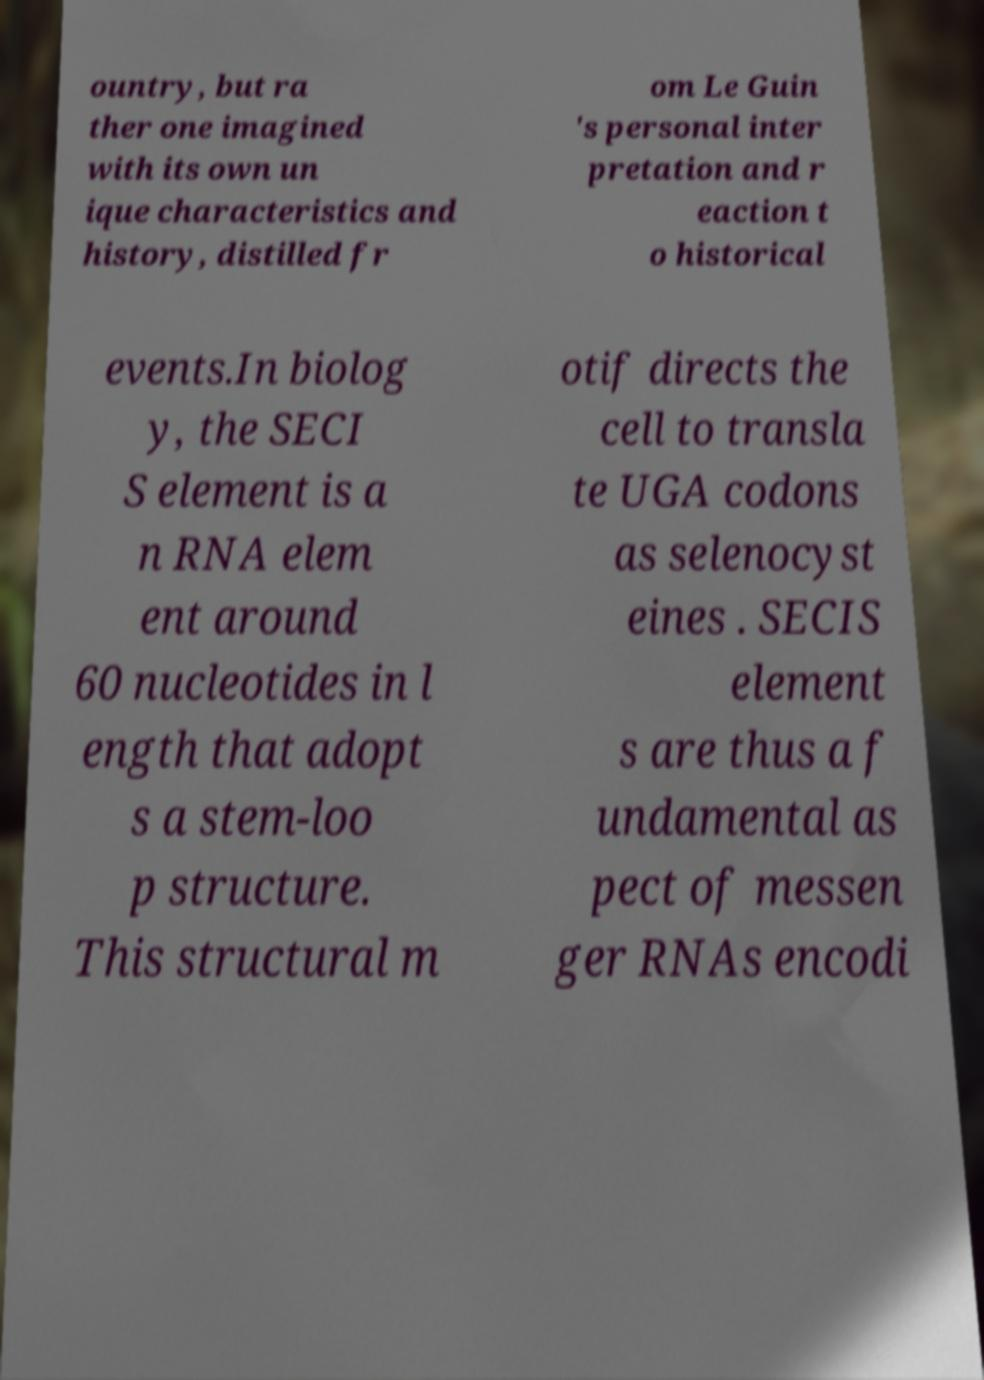What messages or text are displayed in this image? I need them in a readable, typed format. ountry, but ra ther one imagined with its own un ique characteristics and history, distilled fr om Le Guin 's personal inter pretation and r eaction t o historical events.In biolog y, the SECI S element is a n RNA elem ent around 60 nucleotides in l ength that adopt s a stem-loo p structure. This structural m otif directs the cell to transla te UGA codons as selenocyst eines . SECIS element s are thus a f undamental as pect of messen ger RNAs encodi 